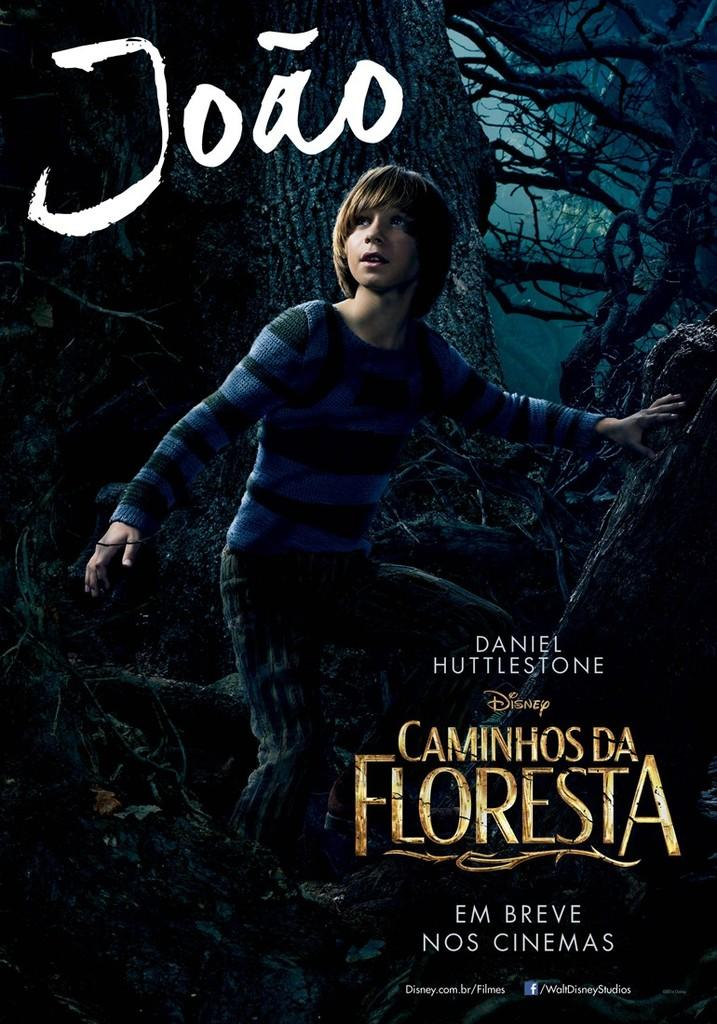<image>
Summarize the visual content of the image. A poster for a Disney movie that shows a boy in some woods and says Caminhosda Floresta. 